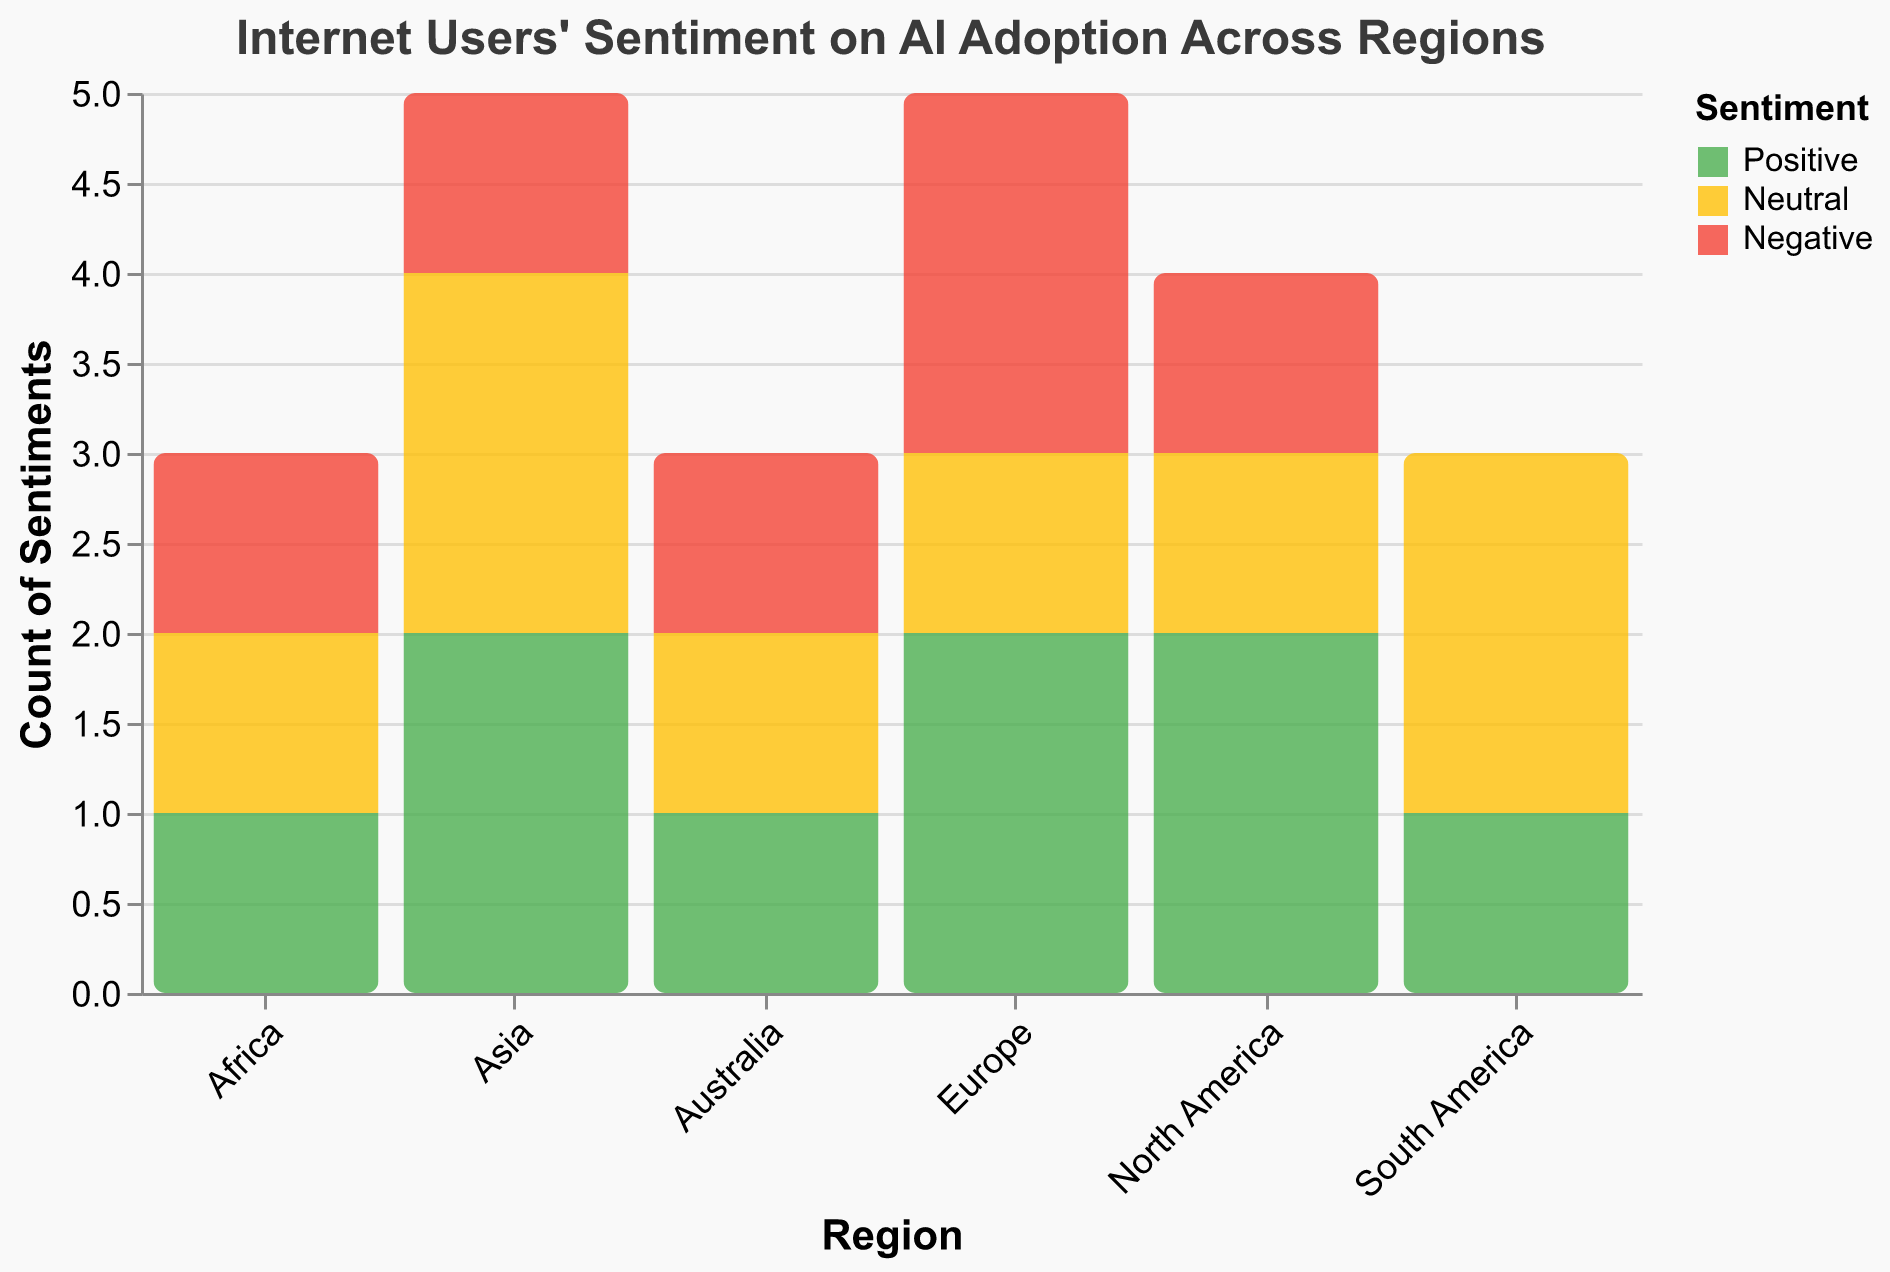What's the title of the figure? The title is typically at the top of the figure and describes the content. In this case, it is "Internet Users' Sentiment on AI Adoption Across Regions".
Answer: Internet Users' Sentiment on AI Adoption Across Regions Which region has the highest number of positive sentiments? To determine this, locate the bars for each region and compare the heights of the bars colored green (indicating positive sentiment).
Answer: Asia How many neutral sentiments are there in total across all regions? Count the heights of all yellow bars, which represent neutral sentiments. Summing the counts from each region gives the total number.
Answer: 7 Compare the number of negative sentiments between Europe and North America. Which region has more? Check the height of red bars (indicating negative sentiment) for both Europe and North America. Europe has three negative sentiments and North America has one. So, Europe has more.
Answer: Europe What is the difference in the number of positive sentiments between Asia and Africa? Asia has three green bars while Africa has one. Subtract the number of positive sentiments in Africa from that in Asia (3 - 1).
Answer: 2 How many total sentiments are recorded for North America? Sum the counts of all types of sentiments (positive, neutral, and negative) for North America.
Answer: 4 What is the ratio of positive to negative sentiments in Europe? Count the positive sentiments (2) and negative sentiments (3) in Europe. The ratio is 2:3.
Answer: 2:3 Which region has an equal number of neutral and negative sentiments? Find the regions where the heights of the yellow bars (neutral) and red bars (negative) are the same. South America and Australia both have equal counts for neutral and negative sentiments (2 and 1, respectively).
Answer: South America and Australia What percentage of the total sentiments are positive in Africa? First, count the total number of sentiments in Africa (3). Then, find the number of positive sentiments (1). The percentage is (1/3) * 100.
Answer: 33.3% Which region shows a balanced distribution across all three sentiment types (positive, neutral, and negative)? Look for a region where the heights of the green, yellow, and red bars are approximately the same. Australia and South America each have a near-equal distribution of sentiments.
Answer: Australia and South America 